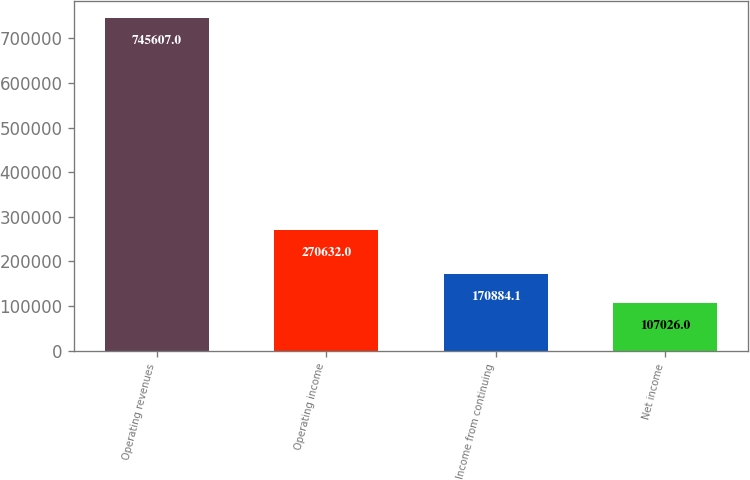Convert chart to OTSL. <chart><loc_0><loc_0><loc_500><loc_500><bar_chart><fcel>Operating revenues<fcel>Operating income<fcel>Income from continuing<fcel>Net income<nl><fcel>745607<fcel>270632<fcel>170884<fcel>107026<nl></chart> 